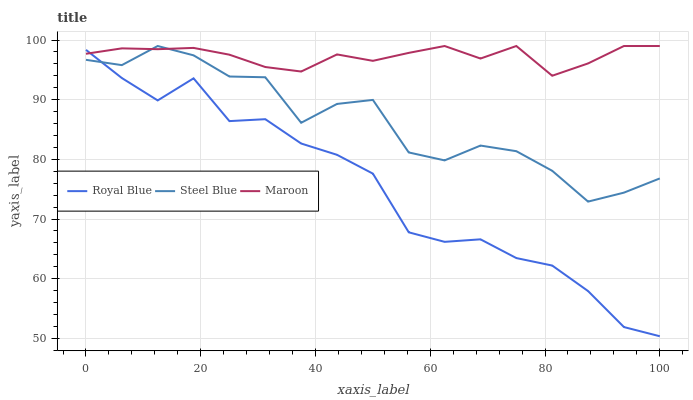Does Royal Blue have the minimum area under the curve?
Answer yes or no. Yes. Does Maroon have the maximum area under the curve?
Answer yes or no. Yes. Does Steel Blue have the minimum area under the curve?
Answer yes or no. No. Does Steel Blue have the maximum area under the curve?
Answer yes or no. No. Is Maroon the smoothest?
Answer yes or no. Yes. Is Steel Blue the roughest?
Answer yes or no. Yes. Is Steel Blue the smoothest?
Answer yes or no. No. Is Maroon the roughest?
Answer yes or no. No. Does Royal Blue have the lowest value?
Answer yes or no. Yes. Does Steel Blue have the lowest value?
Answer yes or no. No. Does Maroon have the highest value?
Answer yes or no. Yes. Does Steel Blue intersect Royal Blue?
Answer yes or no. Yes. Is Steel Blue less than Royal Blue?
Answer yes or no. No. Is Steel Blue greater than Royal Blue?
Answer yes or no. No. 